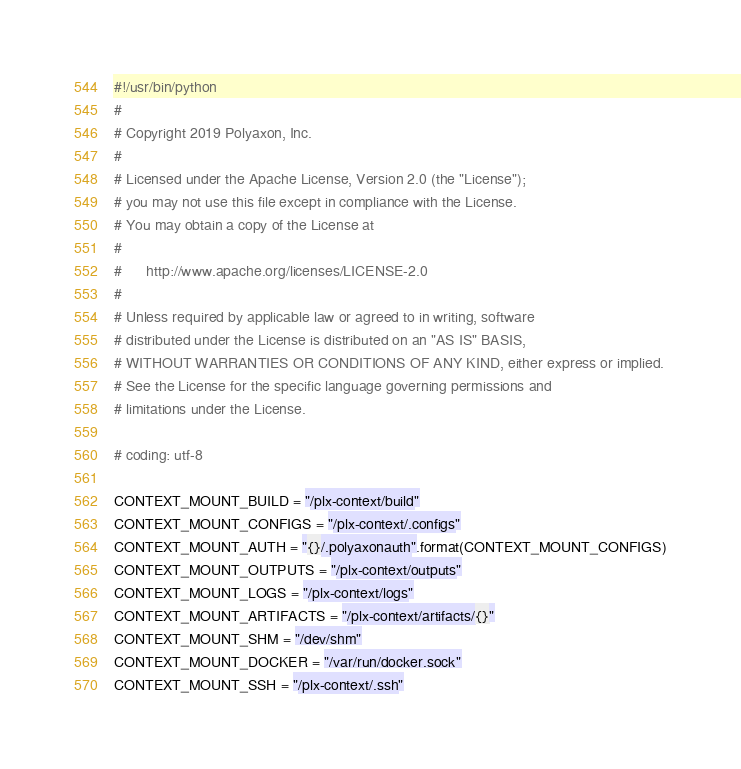Convert code to text. <code><loc_0><loc_0><loc_500><loc_500><_Python_>#!/usr/bin/python
#
# Copyright 2019 Polyaxon, Inc.
#
# Licensed under the Apache License, Version 2.0 (the "License");
# you may not use this file except in compliance with the License.
# You may obtain a copy of the License at
#
#      http://www.apache.org/licenses/LICENSE-2.0
#
# Unless required by applicable law or agreed to in writing, software
# distributed under the License is distributed on an "AS IS" BASIS,
# WITHOUT WARRANTIES OR CONDITIONS OF ANY KIND, either express or implied.
# See the License for the specific language governing permissions and
# limitations under the License.

# coding: utf-8

CONTEXT_MOUNT_BUILD = "/plx-context/build"
CONTEXT_MOUNT_CONFIGS = "/plx-context/.configs"
CONTEXT_MOUNT_AUTH = "{}/.polyaxonauth".format(CONTEXT_MOUNT_CONFIGS)
CONTEXT_MOUNT_OUTPUTS = "/plx-context/outputs"
CONTEXT_MOUNT_LOGS = "/plx-context/logs"
CONTEXT_MOUNT_ARTIFACTS = "/plx-context/artifacts/{}"
CONTEXT_MOUNT_SHM = "/dev/shm"
CONTEXT_MOUNT_DOCKER = "/var/run/docker.sock"
CONTEXT_MOUNT_SSH = "/plx-context/.ssh"
</code> 